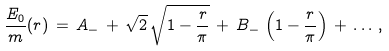<formula> <loc_0><loc_0><loc_500><loc_500>\frac { E _ { 0 } } { m } ( r ) \, = \, A _ { - } \, + \, \sqrt { 2 } \, \sqrt { 1 - \frac { r } { \pi } } \, + \, B _ { - } \, \left ( 1 - \frac { r } { \pi } \right ) \, + \, \dots \, ,</formula> 